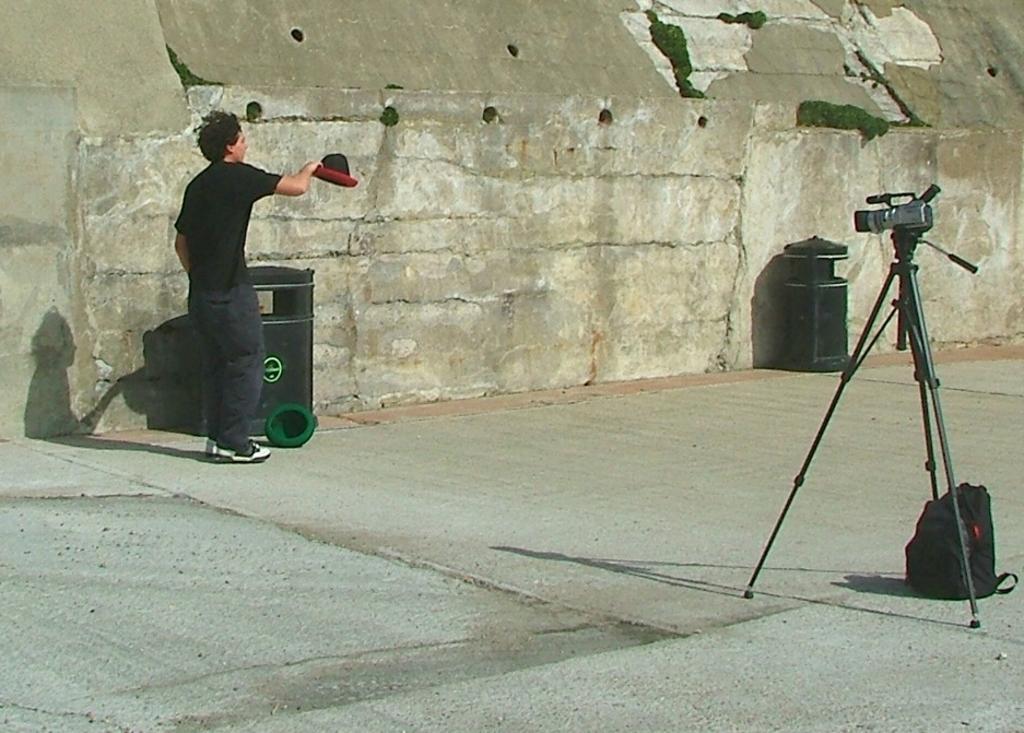How would you summarize this image in a sentence or two? In the picture we can see a path to it, we can see a tripod with a camera on it and near it, we can see a bag which is black in color on the path and some far away from it we can see a man near the wall holding a hat and he is in black T-shirt. 